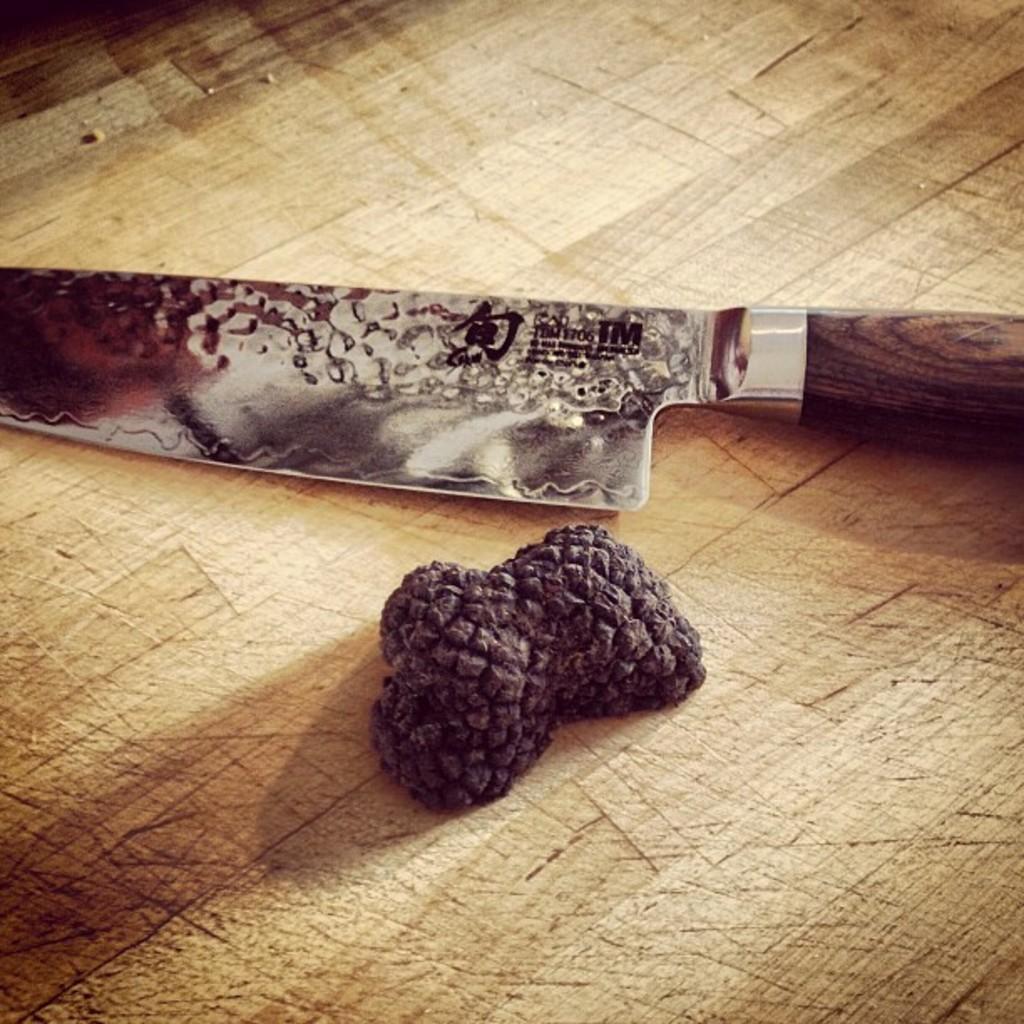Please provide a concise description of this image. In this image we can see a knife and an object placed on the wooden surface. 